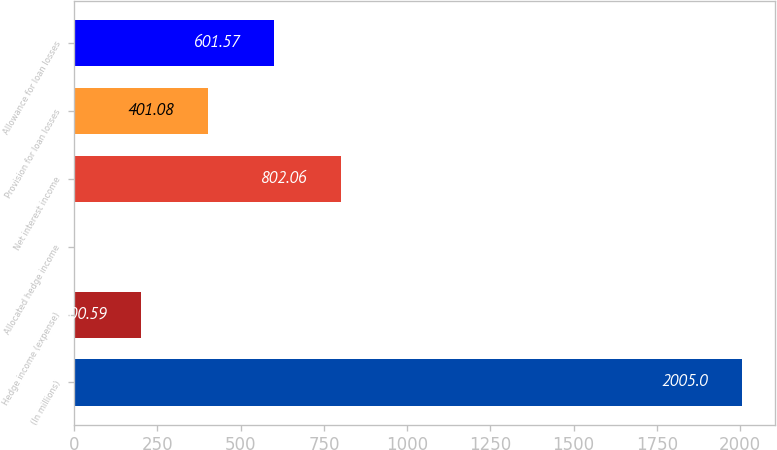Convert chart to OTSL. <chart><loc_0><loc_0><loc_500><loc_500><bar_chart><fcel>(In millions)<fcel>Hedge income (expense)<fcel>Allocated hedge income<fcel>Net interest income<fcel>Provision for loan losses<fcel>Allowance for loan losses<nl><fcel>2005<fcel>200.59<fcel>0.1<fcel>802.06<fcel>401.08<fcel>601.57<nl></chart> 